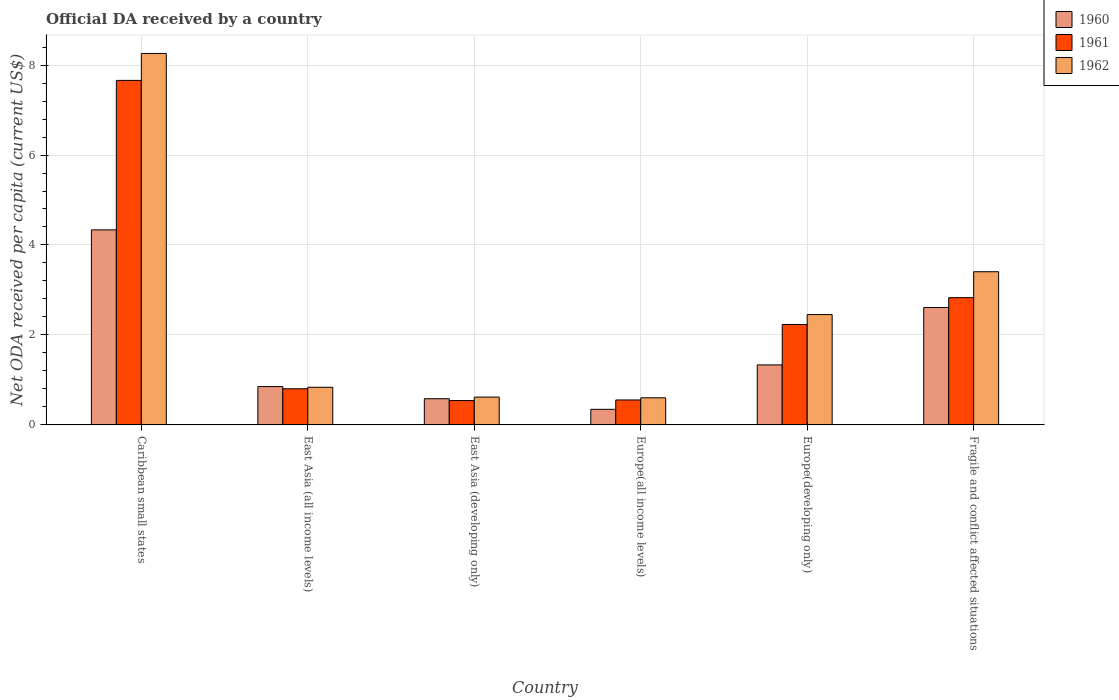How many different coloured bars are there?
Provide a short and direct response. 3. How many bars are there on the 6th tick from the right?
Give a very brief answer. 3. What is the label of the 1st group of bars from the left?
Your response must be concise. Caribbean small states. In how many cases, is the number of bars for a given country not equal to the number of legend labels?
Keep it short and to the point. 0. What is the ODA received in in 1961 in Europe(all income levels)?
Ensure brevity in your answer.  0.55. Across all countries, what is the maximum ODA received in in 1961?
Your answer should be compact. 7.66. Across all countries, what is the minimum ODA received in in 1960?
Your answer should be compact. 0.35. In which country was the ODA received in in 1960 maximum?
Your response must be concise. Caribbean small states. In which country was the ODA received in in 1962 minimum?
Provide a succinct answer. Europe(all income levels). What is the total ODA received in in 1962 in the graph?
Provide a succinct answer. 16.17. What is the difference between the ODA received in in 1962 in East Asia (all income levels) and that in East Asia (developing only)?
Make the answer very short. 0.22. What is the difference between the ODA received in in 1960 in East Asia (developing only) and the ODA received in in 1961 in Europe(all income levels)?
Your answer should be very brief. 0.03. What is the average ODA received in in 1962 per country?
Your answer should be compact. 2.7. What is the difference between the ODA received in of/in 1961 and ODA received in of/in 1960 in Europe(developing only)?
Provide a succinct answer. 0.9. In how many countries, is the ODA received in in 1961 greater than 2.8 US$?
Your response must be concise. 2. What is the ratio of the ODA received in in 1962 in Europe(all income levels) to that in Europe(developing only)?
Keep it short and to the point. 0.25. Is the difference between the ODA received in in 1961 in Caribbean small states and Europe(developing only) greater than the difference between the ODA received in in 1960 in Caribbean small states and Europe(developing only)?
Your response must be concise. Yes. What is the difference between the highest and the second highest ODA received in in 1961?
Your answer should be compact. 0.6. What is the difference between the highest and the lowest ODA received in in 1961?
Ensure brevity in your answer.  7.12. In how many countries, is the ODA received in in 1961 greater than the average ODA received in in 1961 taken over all countries?
Provide a short and direct response. 2. Is the sum of the ODA received in in 1962 in East Asia (all income levels) and Europe(all income levels) greater than the maximum ODA received in in 1960 across all countries?
Offer a very short reply. No. What does the 1st bar from the left in East Asia (all income levels) represents?
Your response must be concise. 1960. What does the 3rd bar from the right in East Asia (developing only) represents?
Offer a terse response. 1960. How many bars are there?
Your answer should be very brief. 18. Are all the bars in the graph horizontal?
Provide a succinct answer. No. How many countries are there in the graph?
Offer a terse response. 6. Are the values on the major ticks of Y-axis written in scientific E-notation?
Give a very brief answer. No. Does the graph contain any zero values?
Offer a very short reply. No. What is the title of the graph?
Provide a succinct answer. Official DA received by a country. Does "2005" appear as one of the legend labels in the graph?
Your answer should be compact. No. What is the label or title of the X-axis?
Provide a short and direct response. Country. What is the label or title of the Y-axis?
Make the answer very short. Net ODA received per capita (current US$). What is the Net ODA received per capita (current US$) in 1960 in Caribbean small states?
Provide a succinct answer. 4.34. What is the Net ODA received per capita (current US$) in 1961 in Caribbean small states?
Provide a short and direct response. 7.66. What is the Net ODA received per capita (current US$) in 1962 in Caribbean small states?
Offer a very short reply. 8.26. What is the Net ODA received per capita (current US$) in 1960 in East Asia (all income levels)?
Offer a terse response. 0.85. What is the Net ODA received per capita (current US$) in 1961 in East Asia (all income levels)?
Keep it short and to the point. 0.8. What is the Net ODA received per capita (current US$) of 1962 in East Asia (all income levels)?
Give a very brief answer. 0.84. What is the Net ODA received per capita (current US$) of 1960 in East Asia (developing only)?
Make the answer very short. 0.58. What is the Net ODA received per capita (current US$) of 1961 in East Asia (developing only)?
Provide a short and direct response. 0.54. What is the Net ODA received per capita (current US$) in 1962 in East Asia (developing only)?
Make the answer very short. 0.62. What is the Net ODA received per capita (current US$) of 1960 in Europe(all income levels)?
Your answer should be compact. 0.35. What is the Net ODA received per capita (current US$) in 1961 in Europe(all income levels)?
Your response must be concise. 0.55. What is the Net ODA received per capita (current US$) in 1962 in Europe(all income levels)?
Offer a terse response. 0.6. What is the Net ODA received per capita (current US$) of 1960 in Europe(developing only)?
Your answer should be compact. 1.33. What is the Net ODA received per capita (current US$) of 1961 in Europe(developing only)?
Give a very brief answer. 2.23. What is the Net ODA received per capita (current US$) of 1962 in Europe(developing only)?
Give a very brief answer. 2.45. What is the Net ODA received per capita (current US$) of 1960 in Fragile and conflict affected situations?
Your response must be concise. 2.61. What is the Net ODA received per capita (current US$) of 1961 in Fragile and conflict affected situations?
Keep it short and to the point. 2.83. What is the Net ODA received per capita (current US$) in 1962 in Fragile and conflict affected situations?
Offer a terse response. 3.41. Across all countries, what is the maximum Net ODA received per capita (current US$) in 1960?
Your answer should be compact. 4.34. Across all countries, what is the maximum Net ODA received per capita (current US$) in 1961?
Provide a short and direct response. 7.66. Across all countries, what is the maximum Net ODA received per capita (current US$) in 1962?
Provide a succinct answer. 8.26. Across all countries, what is the minimum Net ODA received per capita (current US$) in 1960?
Ensure brevity in your answer.  0.35. Across all countries, what is the minimum Net ODA received per capita (current US$) of 1961?
Ensure brevity in your answer.  0.54. Across all countries, what is the minimum Net ODA received per capita (current US$) in 1962?
Ensure brevity in your answer.  0.6. What is the total Net ODA received per capita (current US$) of 1960 in the graph?
Your answer should be compact. 10.06. What is the total Net ODA received per capita (current US$) of 1961 in the graph?
Your answer should be compact. 14.62. What is the total Net ODA received per capita (current US$) in 1962 in the graph?
Your answer should be very brief. 16.17. What is the difference between the Net ODA received per capita (current US$) in 1960 in Caribbean small states and that in East Asia (all income levels)?
Give a very brief answer. 3.48. What is the difference between the Net ODA received per capita (current US$) in 1961 in Caribbean small states and that in East Asia (all income levels)?
Keep it short and to the point. 6.86. What is the difference between the Net ODA received per capita (current US$) in 1962 in Caribbean small states and that in East Asia (all income levels)?
Give a very brief answer. 7.42. What is the difference between the Net ODA received per capita (current US$) of 1960 in Caribbean small states and that in East Asia (developing only)?
Offer a very short reply. 3.75. What is the difference between the Net ODA received per capita (current US$) in 1961 in Caribbean small states and that in East Asia (developing only)?
Provide a short and direct response. 7.12. What is the difference between the Net ODA received per capita (current US$) of 1962 in Caribbean small states and that in East Asia (developing only)?
Your answer should be compact. 7.64. What is the difference between the Net ODA received per capita (current US$) in 1960 in Caribbean small states and that in Europe(all income levels)?
Make the answer very short. 3.99. What is the difference between the Net ODA received per capita (current US$) of 1961 in Caribbean small states and that in Europe(all income levels)?
Offer a terse response. 7.1. What is the difference between the Net ODA received per capita (current US$) of 1962 in Caribbean small states and that in Europe(all income levels)?
Offer a terse response. 7.65. What is the difference between the Net ODA received per capita (current US$) in 1960 in Caribbean small states and that in Europe(developing only)?
Provide a short and direct response. 3. What is the difference between the Net ODA received per capita (current US$) in 1961 in Caribbean small states and that in Europe(developing only)?
Provide a succinct answer. 5.43. What is the difference between the Net ODA received per capita (current US$) in 1962 in Caribbean small states and that in Europe(developing only)?
Your response must be concise. 5.8. What is the difference between the Net ODA received per capita (current US$) of 1960 in Caribbean small states and that in Fragile and conflict affected situations?
Offer a very short reply. 1.73. What is the difference between the Net ODA received per capita (current US$) in 1961 in Caribbean small states and that in Fragile and conflict affected situations?
Provide a short and direct response. 4.83. What is the difference between the Net ODA received per capita (current US$) in 1962 in Caribbean small states and that in Fragile and conflict affected situations?
Keep it short and to the point. 4.85. What is the difference between the Net ODA received per capita (current US$) in 1960 in East Asia (all income levels) and that in East Asia (developing only)?
Keep it short and to the point. 0.27. What is the difference between the Net ODA received per capita (current US$) of 1961 in East Asia (all income levels) and that in East Asia (developing only)?
Make the answer very short. 0.26. What is the difference between the Net ODA received per capita (current US$) of 1962 in East Asia (all income levels) and that in East Asia (developing only)?
Your answer should be very brief. 0.22. What is the difference between the Net ODA received per capita (current US$) of 1960 in East Asia (all income levels) and that in Europe(all income levels)?
Your answer should be very brief. 0.51. What is the difference between the Net ODA received per capita (current US$) of 1961 in East Asia (all income levels) and that in Europe(all income levels)?
Your answer should be very brief. 0.25. What is the difference between the Net ODA received per capita (current US$) in 1962 in East Asia (all income levels) and that in Europe(all income levels)?
Ensure brevity in your answer.  0.23. What is the difference between the Net ODA received per capita (current US$) in 1960 in East Asia (all income levels) and that in Europe(developing only)?
Offer a very short reply. -0.48. What is the difference between the Net ODA received per capita (current US$) in 1961 in East Asia (all income levels) and that in Europe(developing only)?
Provide a short and direct response. -1.43. What is the difference between the Net ODA received per capita (current US$) in 1962 in East Asia (all income levels) and that in Europe(developing only)?
Provide a short and direct response. -1.62. What is the difference between the Net ODA received per capita (current US$) in 1960 in East Asia (all income levels) and that in Fragile and conflict affected situations?
Your answer should be very brief. -1.76. What is the difference between the Net ODA received per capita (current US$) of 1961 in East Asia (all income levels) and that in Fragile and conflict affected situations?
Provide a short and direct response. -2.03. What is the difference between the Net ODA received per capita (current US$) of 1962 in East Asia (all income levels) and that in Fragile and conflict affected situations?
Ensure brevity in your answer.  -2.57. What is the difference between the Net ODA received per capita (current US$) of 1960 in East Asia (developing only) and that in Europe(all income levels)?
Your response must be concise. 0.24. What is the difference between the Net ODA received per capita (current US$) in 1961 in East Asia (developing only) and that in Europe(all income levels)?
Offer a terse response. -0.01. What is the difference between the Net ODA received per capita (current US$) of 1962 in East Asia (developing only) and that in Europe(all income levels)?
Your answer should be compact. 0.02. What is the difference between the Net ODA received per capita (current US$) of 1960 in East Asia (developing only) and that in Europe(developing only)?
Provide a succinct answer. -0.75. What is the difference between the Net ODA received per capita (current US$) of 1961 in East Asia (developing only) and that in Europe(developing only)?
Offer a very short reply. -1.69. What is the difference between the Net ODA received per capita (current US$) in 1962 in East Asia (developing only) and that in Europe(developing only)?
Keep it short and to the point. -1.83. What is the difference between the Net ODA received per capita (current US$) in 1960 in East Asia (developing only) and that in Fragile and conflict affected situations?
Ensure brevity in your answer.  -2.03. What is the difference between the Net ODA received per capita (current US$) of 1961 in East Asia (developing only) and that in Fragile and conflict affected situations?
Keep it short and to the point. -2.29. What is the difference between the Net ODA received per capita (current US$) of 1962 in East Asia (developing only) and that in Fragile and conflict affected situations?
Give a very brief answer. -2.79. What is the difference between the Net ODA received per capita (current US$) in 1960 in Europe(all income levels) and that in Europe(developing only)?
Keep it short and to the point. -0.99. What is the difference between the Net ODA received per capita (current US$) in 1961 in Europe(all income levels) and that in Europe(developing only)?
Offer a very short reply. -1.68. What is the difference between the Net ODA received per capita (current US$) of 1962 in Europe(all income levels) and that in Europe(developing only)?
Make the answer very short. -1.85. What is the difference between the Net ODA received per capita (current US$) in 1960 in Europe(all income levels) and that in Fragile and conflict affected situations?
Your response must be concise. -2.26. What is the difference between the Net ODA received per capita (current US$) of 1961 in Europe(all income levels) and that in Fragile and conflict affected situations?
Offer a terse response. -2.27. What is the difference between the Net ODA received per capita (current US$) of 1962 in Europe(all income levels) and that in Fragile and conflict affected situations?
Make the answer very short. -2.8. What is the difference between the Net ODA received per capita (current US$) of 1960 in Europe(developing only) and that in Fragile and conflict affected situations?
Provide a short and direct response. -1.28. What is the difference between the Net ODA received per capita (current US$) of 1961 in Europe(developing only) and that in Fragile and conflict affected situations?
Give a very brief answer. -0.6. What is the difference between the Net ODA received per capita (current US$) in 1962 in Europe(developing only) and that in Fragile and conflict affected situations?
Give a very brief answer. -0.95. What is the difference between the Net ODA received per capita (current US$) in 1960 in Caribbean small states and the Net ODA received per capita (current US$) in 1961 in East Asia (all income levels)?
Your answer should be compact. 3.53. What is the difference between the Net ODA received per capita (current US$) of 1960 in Caribbean small states and the Net ODA received per capita (current US$) of 1962 in East Asia (all income levels)?
Keep it short and to the point. 3.5. What is the difference between the Net ODA received per capita (current US$) in 1961 in Caribbean small states and the Net ODA received per capita (current US$) in 1962 in East Asia (all income levels)?
Make the answer very short. 6.82. What is the difference between the Net ODA received per capita (current US$) in 1960 in Caribbean small states and the Net ODA received per capita (current US$) in 1961 in East Asia (developing only)?
Your answer should be compact. 3.79. What is the difference between the Net ODA received per capita (current US$) in 1960 in Caribbean small states and the Net ODA received per capita (current US$) in 1962 in East Asia (developing only)?
Offer a terse response. 3.72. What is the difference between the Net ODA received per capita (current US$) in 1961 in Caribbean small states and the Net ODA received per capita (current US$) in 1962 in East Asia (developing only)?
Your answer should be very brief. 7.04. What is the difference between the Net ODA received per capita (current US$) of 1960 in Caribbean small states and the Net ODA received per capita (current US$) of 1961 in Europe(all income levels)?
Ensure brevity in your answer.  3.78. What is the difference between the Net ODA received per capita (current US$) of 1960 in Caribbean small states and the Net ODA received per capita (current US$) of 1962 in Europe(all income levels)?
Provide a short and direct response. 3.73. What is the difference between the Net ODA received per capita (current US$) in 1961 in Caribbean small states and the Net ODA received per capita (current US$) in 1962 in Europe(all income levels)?
Keep it short and to the point. 7.06. What is the difference between the Net ODA received per capita (current US$) of 1960 in Caribbean small states and the Net ODA received per capita (current US$) of 1961 in Europe(developing only)?
Provide a succinct answer. 2.1. What is the difference between the Net ODA received per capita (current US$) in 1960 in Caribbean small states and the Net ODA received per capita (current US$) in 1962 in Europe(developing only)?
Your answer should be very brief. 1.88. What is the difference between the Net ODA received per capita (current US$) of 1961 in Caribbean small states and the Net ODA received per capita (current US$) of 1962 in Europe(developing only)?
Your answer should be compact. 5.21. What is the difference between the Net ODA received per capita (current US$) of 1960 in Caribbean small states and the Net ODA received per capita (current US$) of 1961 in Fragile and conflict affected situations?
Make the answer very short. 1.51. What is the difference between the Net ODA received per capita (current US$) of 1960 in Caribbean small states and the Net ODA received per capita (current US$) of 1962 in Fragile and conflict affected situations?
Offer a very short reply. 0.93. What is the difference between the Net ODA received per capita (current US$) of 1961 in Caribbean small states and the Net ODA received per capita (current US$) of 1962 in Fragile and conflict affected situations?
Provide a short and direct response. 4.25. What is the difference between the Net ODA received per capita (current US$) in 1960 in East Asia (all income levels) and the Net ODA received per capita (current US$) in 1961 in East Asia (developing only)?
Keep it short and to the point. 0.31. What is the difference between the Net ODA received per capita (current US$) in 1960 in East Asia (all income levels) and the Net ODA received per capita (current US$) in 1962 in East Asia (developing only)?
Provide a short and direct response. 0.23. What is the difference between the Net ODA received per capita (current US$) of 1961 in East Asia (all income levels) and the Net ODA received per capita (current US$) of 1962 in East Asia (developing only)?
Ensure brevity in your answer.  0.19. What is the difference between the Net ODA received per capita (current US$) in 1960 in East Asia (all income levels) and the Net ODA received per capita (current US$) in 1961 in Europe(all income levels)?
Offer a terse response. 0.3. What is the difference between the Net ODA received per capita (current US$) of 1960 in East Asia (all income levels) and the Net ODA received per capita (current US$) of 1962 in Europe(all income levels)?
Give a very brief answer. 0.25. What is the difference between the Net ODA received per capita (current US$) of 1961 in East Asia (all income levels) and the Net ODA received per capita (current US$) of 1962 in Europe(all income levels)?
Offer a terse response. 0.2. What is the difference between the Net ODA received per capita (current US$) in 1960 in East Asia (all income levels) and the Net ODA received per capita (current US$) in 1961 in Europe(developing only)?
Provide a short and direct response. -1.38. What is the difference between the Net ODA received per capita (current US$) in 1960 in East Asia (all income levels) and the Net ODA received per capita (current US$) in 1962 in Europe(developing only)?
Offer a very short reply. -1.6. What is the difference between the Net ODA received per capita (current US$) in 1961 in East Asia (all income levels) and the Net ODA received per capita (current US$) in 1962 in Europe(developing only)?
Keep it short and to the point. -1.65. What is the difference between the Net ODA received per capita (current US$) of 1960 in East Asia (all income levels) and the Net ODA received per capita (current US$) of 1961 in Fragile and conflict affected situations?
Your answer should be compact. -1.98. What is the difference between the Net ODA received per capita (current US$) of 1960 in East Asia (all income levels) and the Net ODA received per capita (current US$) of 1962 in Fragile and conflict affected situations?
Give a very brief answer. -2.55. What is the difference between the Net ODA received per capita (current US$) in 1961 in East Asia (all income levels) and the Net ODA received per capita (current US$) in 1962 in Fragile and conflict affected situations?
Your answer should be very brief. -2.6. What is the difference between the Net ODA received per capita (current US$) of 1960 in East Asia (developing only) and the Net ODA received per capita (current US$) of 1961 in Europe(all income levels)?
Provide a succinct answer. 0.03. What is the difference between the Net ODA received per capita (current US$) of 1960 in East Asia (developing only) and the Net ODA received per capita (current US$) of 1962 in Europe(all income levels)?
Provide a short and direct response. -0.02. What is the difference between the Net ODA received per capita (current US$) in 1961 in East Asia (developing only) and the Net ODA received per capita (current US$) in 1962 in Europe(all income levels)?
Make the answer very short. -0.06. What is the difference between the Net ODA received per capita (current US$) in 1960 in East Asia (developing only) and the Net ODA received per capita (current US$) in 1961 in Europe(developing only)?
Make the answer very short. -1.65. What is the difference between the Net ODA received per capita (current US$) of 1960 in East Asia (developing only) and the Net ODA received per capita (current US$) of 1962 in Europe(developing only)?
Give a very brief answer. -1.87. What is the difference between the Net ODA received per capita (current US$) of 1961 in East Asia (developing only) and the Net ODA received per capita (current US$) of 1962 in Europe(developing only)?
Offer a very short reply. -1.91. What is the difference between the Net ODA received per capita (current US$) in 1960 in East Asia (developing only) and the Net ODA received per capita (current US$) in 1961 in Fragile and conflict affected situations?
Your response must be concise. -2.25. What is the difference between the Net ODA received per capita (current US$) of 1960 in East Asia (developing only) and the Net ODA received per capita (current US$) of 1962 in Fragile and conflict affected situations?
Ensure brevity in your answer.  -2.82. What is the difference between the Net ODA received per capita (current US$) in 1961 in East Asia (developing only) and the Net ODA received per capita (current US$) in 1962 in Fragile and conflict affected situations?
Provide a succinct answer. -2.86. What is the difference between the Net ODA received per capita (current US$) in 1960 in Europe(all income levels) and the Net ODA received per capita (current US$) in 1961 in Europe(developing only)?
Your answer should be compact. -1.89. What is the difference between the Net ODA received per capita (current US$) of 1960 in Europe(all income levels) and the Net ODA received per capita (current US$) of 1962 in Europe(developing only)?
Provide a short and direct response. -2.11. What is the difference between the Net ODA received per capita (current US$) of 1961 in Europe(all income levels) and the Net ODA received per capita (current US$) of 1962 in Europe(developing only)?
Ensure brevity in your answer.  -1.9. What is the difference between the Net ODA received per capita (current US$) in 1960 in Europe(all income levels) and the Net ODA received per capita (current US$) in 1961 in Fragile and conflict affected situations?
Your answer should be compact. -2.48. What is the difference between the Net ODA received per capita (current US$) of 1960 in Europe(all income levels) and the Net ODA received per capita (current US$) of 1962 in Fragile and conflict affected situations?
Keep it short and to the point. -3.06. What is the difference between the Net ODA received per capita (current US$) of 1961 in Europe(all income levels) and the Net ODA received per capita (current US$) of 1962 in Fragile and conflict affected situations?
Offer a very short reply. -2.85. What is the difference between the Net ODA received per capita (current US$) in 1960 in Europe(developing only) and the Net ODA received per capita (current US$) in 1961 in Fragile and conflict affected situations?
Give a very brief answer. -1.49. What is the difference between the Net ODA received per capita (current US$) of 1960 in Europe(developing only) and the Net ODA received per capita (current US$) of 1962 in Fragile and conflict affected situations?
Keep it short and to the point. -2.07. What is the difference between the Net ODA received per capita (current US$) in 1961 in Europe(developing only) and the Net ODA received per capita (current US$) in 1962 in Fragile and conflict affected situations?
Provide a short and direct response. -1.17. What is the average Net ODA received per capita (current US$) of 1960 per country?
Keep it short and to the point. 1.68. What is the average Net ODA received per capita (current US$) in 1961 per country?
Your answer should be very brief. 2.44. What is the average Net ODA received per capita (current US$) in 1962 per country?
Your response must be concise. 2.7. What is the difference between the Net ODA received per capita (current US$) in 1960 and Net ODA received per capita (current US$) in 1961 in Caribbean small states?
Provide a succinct answer. -3.32. What is the difference between the Net ODA received per capita (current US$) in 1960 and Net ODA received per capita (current US$) in 1962 in Caribbean small states?
Offer a very short reply. -3.92. What is the difference between the Net ODA received per capita (current US$) in 1961 and Net ODA received per capita (current US$) in 1962 in Caribbean small states?
Your answer should be very brief. -0.6. What is the difference between the Net ODA received per capita (current US$) in 1960 and Net ODA received per capita (current US$) in 1961 in East Asia (all income levels)?
Your answer should be compact. 0.05. What is the difference between the Net ODA received per capita (current US$) of 1960 and Net ODA received per capita (current US$) of 1962 in East Asia (all income levels)?
Your response must be concise. 0.01. What is the difference between the Net ODA received per capita (current US$) in 1961 and Net ODA received per capita (current US$) in 1962 in East Asia (all income levels)?
Provide a succinct answer. -0.03. What is the difference between the Net ODA received per capita (current US$) in 1960 and Net ODA received per capita (current US$) in 1961 in East Asia (developing only)?
Ensure brevity in your answer.  0.04. What is the difference between the Net ODA received per capita (current US$) of 1960 and Net ODA received per capita (current US$) of 1962 in East Asia (developing only)?
Keep it short and to the point. -0.04. What is the difference between the Net ODA received per capita (current US$) in 1961 and Net ODA received per capita (current US$) in 1962 in East Asia (developing only)?
Ensure brevity in your answer.  -0.08. What is the difference between the Net ODA received per capita (current US$) of 1960 and Net ODA received per capita (current US$) of 1961 in Europe(all income levels)?
Your response must be concise. -0.21. What is the difference between the Net ODA received per capita (current US$) in 1960 and Net ODA received per capita (current US$) in 1962 in Europe(all income levels)?
Offer a terse response. -0.26. What is the difference between the Net ODA received per capita (current US$) of 1961 and Net ODA received per capita (current US$) of 1962 in Europe(all income levels)?
Provide a short and direct response. -0.05. What is the difference between the Net ODA received per capita (current US$) in 1960 and Net ODA received per capita (current US$) in 1961 in Europe(developing only)?
Your response must be concise. -0.9. What is the difference between the Net ODA received per capita (current US$) in 1960 and Net ODA received per capita (current US$) in 1962 in Europe(developing only)?
Your response must be concise. -1.12. What is the difference between the Net ODA received per capita (current US$) of 1961 and Net ODA received per capita (current US$) of 1962 in Europe(developing only)?
Your answer should be compact. -0.22. What is the difference between the Net ODA received per capita (current US$) in 1960 and Net ODA received per capita (current US$) in 1961 in Fragile and conflict affected situations?
Your response must be concise. -0.22. What is the difference between the Net ODA received per capita (current US$) of 1960 and Net ODA received per capita (current US$) of 1962 in Fragile and conflict affected situations?
Offer a terse response. -0.8. What is the difference between the Net ODA received per capita (current US$) in 1961 and Net ODA received per capita (current US$) in 1962 in Fragile and conflict affected situations?
Make the answer very short. -0.58. What is the ratio of the Net ODA received per capita (current US$) of 1960 in Caribbean small states to that in East Asia (all income levels)?
Your answer should be compact. 5.09. What is the ratio of the Net ODA received per capita (current US$) of 1961 in Caribbean small states to that in East Asia (all income levels)?
Your answer should be very brief. 9.53. What is the ratio of the Net ODA received per capita (current US$) in 1962 in Caribbean small states to that in East Asia (all income levels)?
Your response must be concise. 9.86. What is the ratio of the Net ODA received per capita (current US$) of 1960 in Caribbean small states to that in East Asia (developing only)?
Keep it short and to the point. 7.45. What is the ratio of the Net ODA received per capita (current US$) in 1961 in Caribbean small states to that in East Asia (developing only)?
Provide a short and direct response. 14.14. What is the ratio of the Net ODA received per capita (current US$) of 1962 in Caribbean small states to that in East Asia (developing only)?
Offer a very short reply. 13.36. What is the ratio of the Net ODA received per capita (current US$) in 1960 in Caribbean small states to that in Europe(all income levels)?
Your answer should be compact. 12.5. What is the ratio of the Net ODA received per capita (current US$) in 1961 in Caribbean small states to that in Europe(all income levels)?
Keep it short and to the point. 13.81. What is the ratio of the Net ODA received per capita (current US$) of 1962 in Caribbean small states to that in Europe(all income levels)?
Provide a succinct answer. 13.69. What is the ratio of the Net ODA received per capita (current US$) in 1960 in Caribbean small states to that in Europe(developing only)?
Offer a very short reply. 3.25. What is the ratio of the Net ODA received per capita (current US$) in 1961 in Caribbean small states to that in Europe(developing only)?
Provide a succinct answer. 3.43. What is the ratio of the Net ODA received per capita (current US$) in 1962 in Caribbean small states to that in Europe(developing only)?
Your answer should be very brief. 3.37. What is the ratio of the Net ODA received per capita (current US$) of 1960 in Caribbean small states to that in Fragile and conflict affected situations?
Ensure brevity in your answer.  1.66. What is the ratio of the Net ODA received per capita (current US$) in 1961 in Caribbean small states to that in Fragile and conflict affected situations?
Your answer should be compact. 2.71. What is the ratio of the Net ODA received per capita (current US$) of 1962 in Caribbean small states to that in Fragile and conflict affected situations?
Offer a terse response. 2.42. What is the ratio of the Net ODA received per capita (current US$) in 1960 in East Asia (all income levels) to that in East Asia (developing only)?
Your response must be concise. 1.46. What is the ratio of the Net ODA received per capita (current US$) of 1961 in East Asia (all income levels) to that in East Asia (developing only)?
Offer a terse response. 1.48. What is the ratio of the Net ODA received per capita (current US$) of 1962 in East Asia (all income levels) to that in East Asia (developing only)?
Your response must be concise. 1.35. What is the ratio of the Net ODA received per capita (current US$) of 1960 in East Asia (all income levels) to that in Europe(all income levels)?
Make the answer very short. 2.46. What is the ratio of the Net ODA received per capita (current US$) of 1961 in East Asia (all income levels) to that in Europe(all income levels)?
Make the answer very short. 1.45. What is the ratio of the Net ODA received per capita (current US$) of 1962 in East Asia (all income levels) to that in Europe(all income levels)?
Provide a short and direct response. 1.39. What is the ratio of the Net ODA received per capita (current US$) in 1960 in East Asia (all income levels) to that in Europe(developing only)?
Your answer should be compact. 0.64. What is the ratio of the Net ODA received per capita (current US$) in 1961 in East Asia (all income levels) to that in Europe(developing only)?
Offer a terse response. 0.36. What is the ratio of the Net ODA received per capita (current US$) of 1962 in East Asia (all income levels) to that in Europe(developing only)?
Your response must be concise. 0.34. What is the ratio of the Net ODA received per capita (current US$) of 1960 in East Asia (all income levels) to that in Fragile and conflict affected situations?
Your answer should be very brief. 0.33. What is the ratio of the Net ODA received per capita (current US$) in 1961 in East Asia (all income levels) to that in Fragile and conflict affected situations?
Offer a terse response. 0.28. What is the ratio of the Net ODA received per capita (current US$) of 1962 in East Asia (all income levels) to that in Fragile and conflict affected situations?
Make the answer very short. 0.25. What is the ratio of the Net ODA received per capita (current US$) of 1960 in East Asia (developing only) to that in Europe(all income levels)?
Ensure brevity in your answer.  1.68. What is the ratio of the Net ODA received per capita (current US$) of 1961 in East Asia (developing only) to that in Europe(all income levels)?
Keep it short and to the point. 0.98. What is the ratio of the Net ODA received per capita (current US$) of 1962 in East Asia (developing only) to that in Europe(all income levels)?
Offer a very short reply. 1.02. What is the ratio of the Net ODA received per capita (current US$) in 1960 in East Asia (developing only) to that in Europe(developing only)?
Provide a succinct answer. 0.44. What is the ratio of the Net ODA received per capita (current US$) in 1961 in East Asia (developing only) to that in Europe(developing only)?
Provide a succinct answer. 0.24. What is the ratio of the Net ODA received per capita (current US$) of 1962 in East Asia (developing only) to that in Europe(developing only)?
Ensure brevity in your answer.  0.25. What is the ratio of the Net ODA received per capita (current US$) of 1960 in East Asia (developing only) to that in Fragile and conflict affected situations?
Make the answer very short. 0.22. What is the ratio of the Net ODA received per capita (current US$) in 1961 in East Asia (developing only) to that in Fragile and conflict affected situations?
Give a very brief answer. 0.19. What is the ratio of the Net ODA received per capita (current US$) in 1962 in East Asia (developing only) to that in Fragile and conflict affected situations?
Offer a very short reply. 0.18. What is the ratio of the Net ODA received per capita (current US$) of 1960 in Europe(all income levels) to that in Europe(developing only)?
Offer a terse response. 0.26. What is the ratio of the Net ODA received per capita (current US$) in 1961 in Europe(all income levels) to that in Europe(developing only)?
Your response must be concise. 0.25. What is the ratio of the Net ODA received per capita (current US$) in 1962 in Europe(all income levels) to that in Europe(developing only)?
Give a very brief answer. 0.25. What is the ratio of the Net ODA received per capita (current US$) of 1960 in Europe(all income levels) to that in Fragile and conflict affected situations?
Provide a short and direct response. 0.13. What is the ratio of the Net ODA received per capita (current US$) of 1961 in Europe(all income levels) to that in Fragile and conflict affected situations?
Give a very brief answer. 0.2. What is the ratio of the Net ODA received per capita (current US$) in 1962 in Europe(all income levels) to that in Fragile and conflict affected situations?
Offer a terse response. 0.18. What is the ratio of the Net ODA received per capita (current US$) of 1960 in Europe(developing only) to that in Fragile and conflict affected situations?
Make the answer very short. 0.51. What is the ratio of the Net ODA received per capita (current US$) of 1961 in Europe(developing only) to that in Fragile and conflict affected situations?
Provide a short and direct response. 0.79. What is the ratio of the Net ODA received per capita (current US$) of 1962 in Europe(developing only) to that in Fragile and conflict affected situations?
Keep it short and to the point. 0.72. What is the difference between the highest and the second highest Net ODA received per capita (current US$) of 1960?
Make the answer very short. 1.73. What is the difference between the highest and the second highest Net ODA received per capita (current US$) of 1961?
Provide a succinct answer. 4.83. What is the difference between the highest and the second highest Net ODA received per capita (current US$) of 1962?
Offer a terse response. 4.85. What is the difference between the highest and the lowest Net ODA received per capita (current US$) of 1960?
Offer a very short reply. 3.99. What is the difference between the highest and the lowest Net ODA received per capita (current US$) of 1961?
Offer a very short reply. 7.12. What is the difference between the highest and the lowest Net ODA received per capita (current US$) of 1962?
Offer a very short reply. 7.65. 